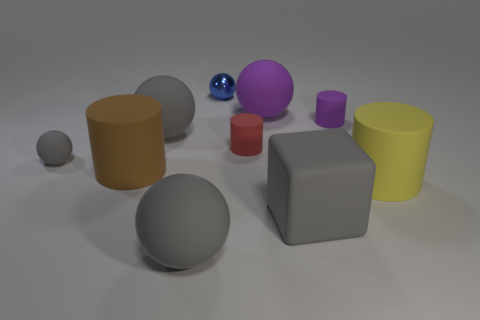Is there a large gray ball made of the same material as the big yellow cylinder?
Your answer should be compact. Yes. What shape is the tiny rubber thing that is the same color as the block?
Offer a terse response. Sphere. What color is the small rubber thing that is to the left of the brown rubber object?
Offer a terse response. Gray. Are there the same number of small blue metallic balls in front of the yellow object and small gray objects behind the blue metal sphere?
Ensure brevity in your answer.  Yes. What is the material of the small object to the right of the tiny matte cylinder left of the tiny purple matte object?
Provide a short and direct response. Rubber. What number of objects are small yellow cubes or large rubber objects behind the large yellow rubber cylinder?
Provide a short and direct response. 3. The red thing that is the same material as the large brown thing is what size?
Your answer should be very brief. Small. Is the number of large purple matte objects that are to the left of the large cube greater than the number of big brown matte cylinders?
Provide a succinct answer. No. There is a gray object that is left of the metallic object and in front of the brown rubber object; what size is it?
Give a very brief answer. Large. There is a brown thing that is the same shape as the big yellow object; what is it made of?
Provide a short and direct response. Rubber. 